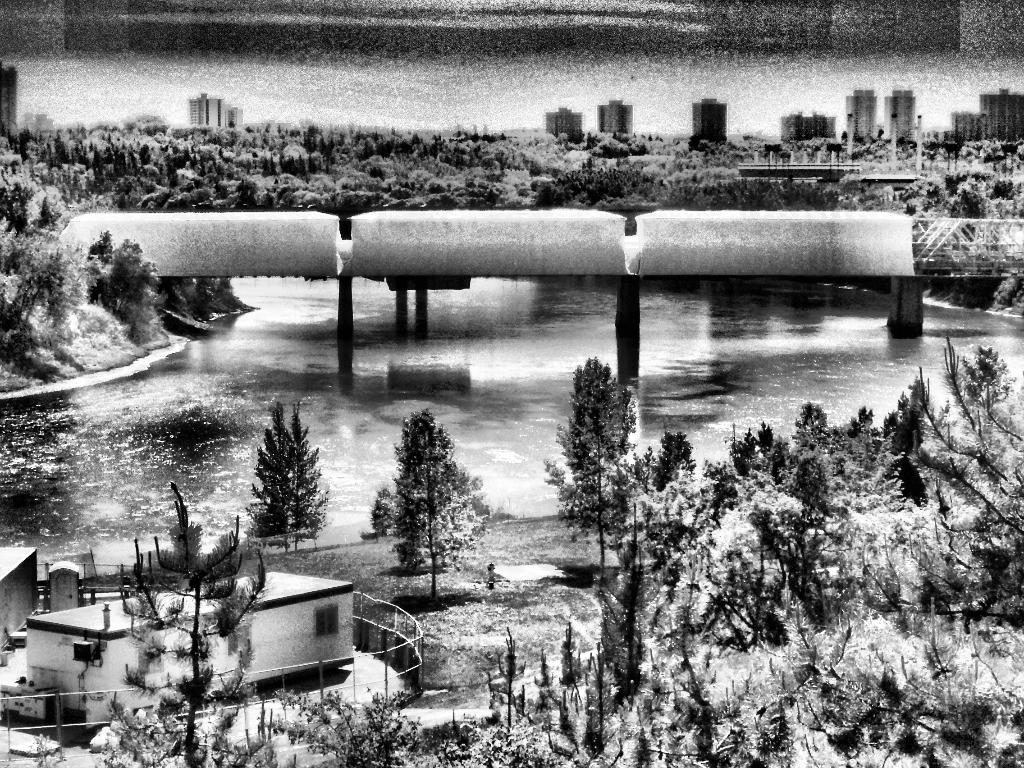What is the color scheme of the image? The image is black and white. What type of natural elements can be seen in the image? There are many trees in the image. What type of man-made structures are present in the image? There are buildings in the image. What is the central feature of the image? There is a water surface in the middle of the image. What is happening on the water surface? There is some construction on the water surface. What type of honey can be seen dripping from the trees in the image? There is no honey present in the image; it is a black and white image featuring trees, buildings, and a water surface with construction. 